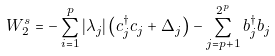Convert formula to latex. <formula><loc_0><loc_0><loc_500><loc_500>W ^ { s } _ { 2 } = - \sum _ { i = 1 } ^ { p } | \lambda _ { j } | \left ( c ^ { \dag } _ { j } c _ { j } + \Delta _ { j } \right ) - \sum _ { j = p + 1 } ^ { 2 ^ { p } } b ^ { \dag } _ { j } b _ { j }</formula> 